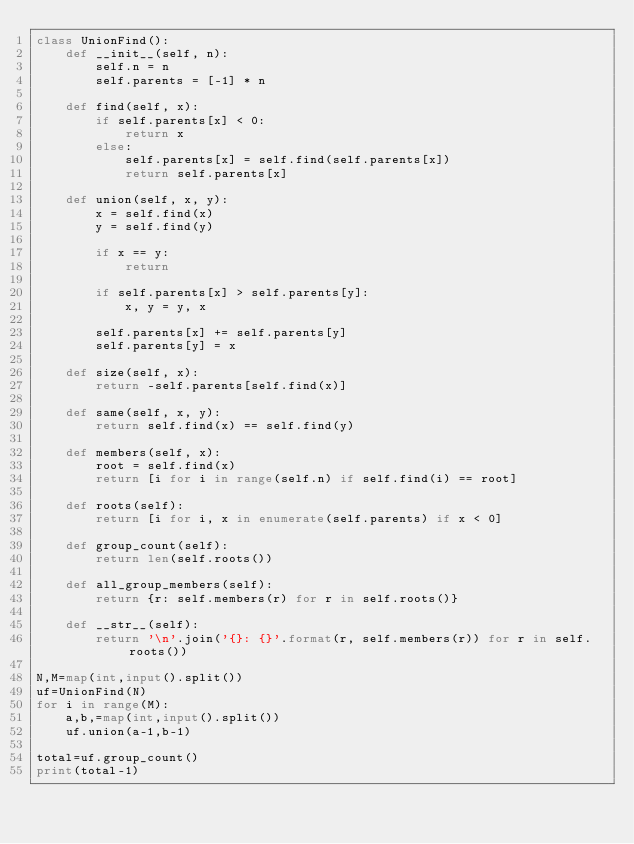<code> <loc_0><loc_0><loc_500><loc_500><_Python_>class UnionFind():
    def __init__(self, n):
        self.n = n
        self.parents = [-1] * n

    def find(self, x):
        if self.parents[x] < 0:
            return x
        else:
            self.parents[x] = self.find(self.parents[x])
            return self.parents[x]

    def union(self, x, y):
        x = self.find(x)
        y = self.find(y)

        if x == y:
            return

        if self.parents[x] > self.parents[y]:
            x, y = y, x

        self.parents[x] += self.parents[y]
        self.parents[y] = x

    def size(self, x):
        return -self.parents[self.find(x)]

    def same(self, x, y):
        return self.find(x) == self.find(y)

    def members(self, x):
        root = self.find(x)
        return [i for i in range(self.n) if self.find(i) == root]

    def roots(self):
        return [i for i, x in enumerate(self.parents) if x < 0]

    def group_count(self):
        return len(self.roots())

    def all_group_members(self):
        return {r: self.members(r) for r in self.roots()}

    def __str__(self):
        return '\n'.join('{}: {}'.format(r, self.members(r)) for r in self.roots())

N,M=map(int,input().split())
uf=UnionFind(N)
for i in range(M):
    a,b,=map(int,input().split())
    uf.union(a-1,b-1)

total=uf.group_count()
print(total-1)
</code> 